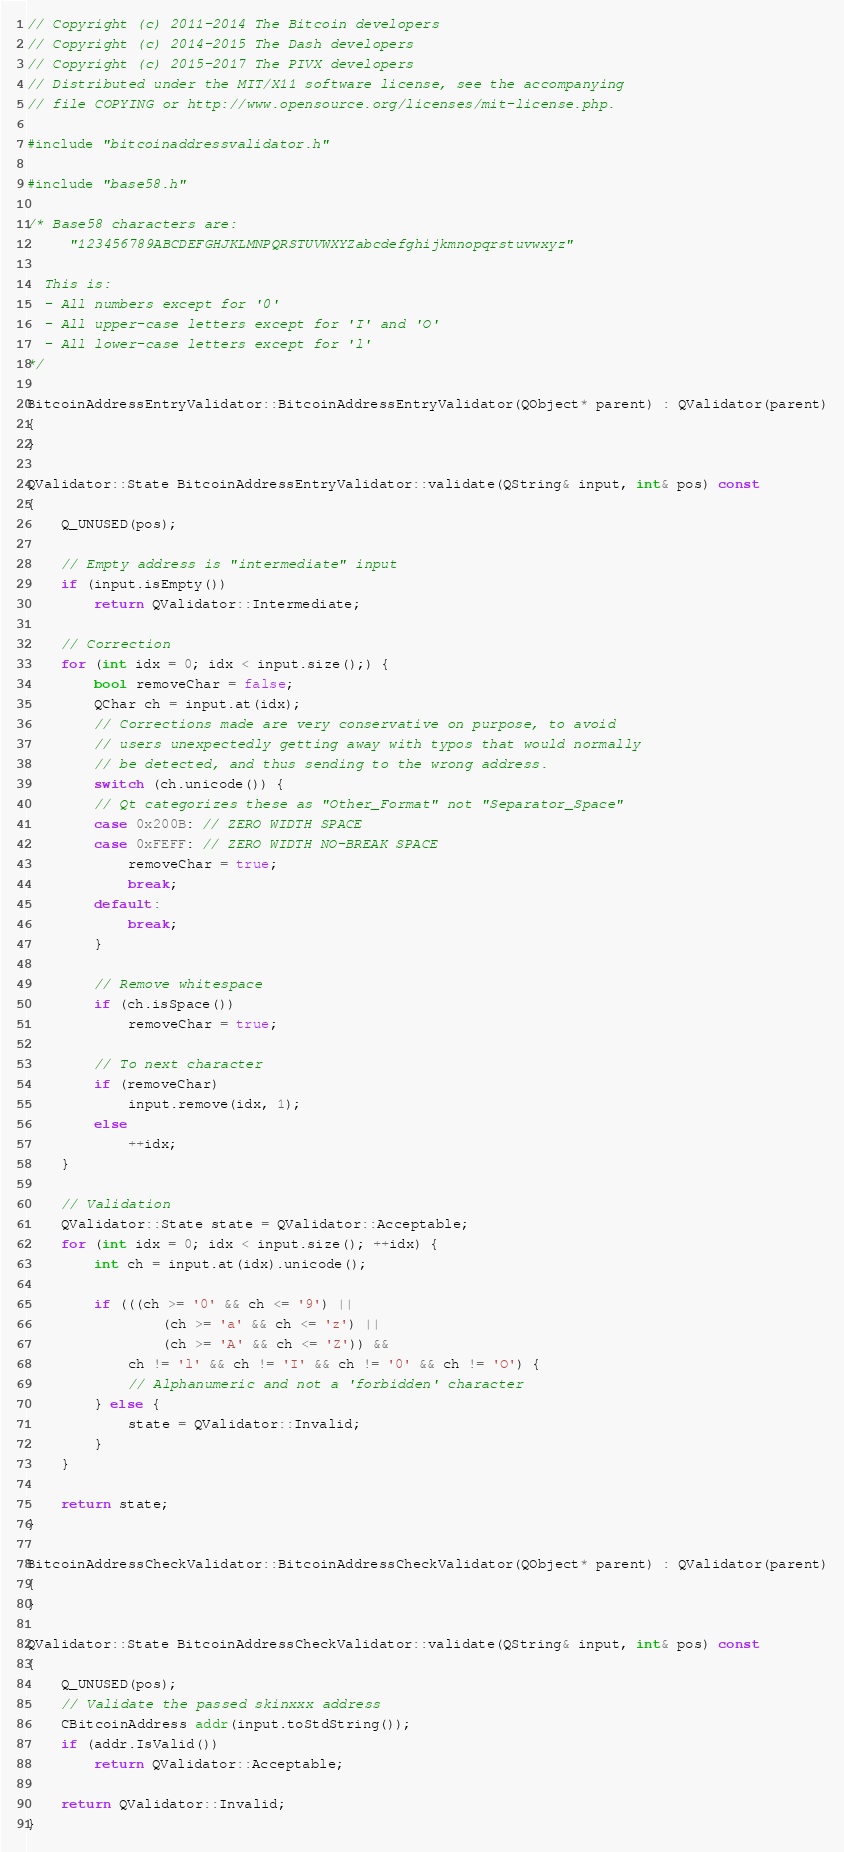<code> <loc_0><loc_0><loc_500><loc_500><_C++_>// Copyright (c) 2011-2014 The Bitcoin developers
// Copyright (c) 2014-2015 The Dash developers
// Copyright (c) 2015-2017 The PIVX developers
// Distributed under the MIT/X11 software license, see the accompanying
// file COPYING or http://www.opensource.org/licenses/mit-license.php.

#include "bitcoinaddressvalidator.h"

#include "base58.h"

/* Base58 characters are:
     "123456789ABCDEFGHJKLMNPQRSTUVWXYZabcdefghijkmnopqrstuvwxyz"

  This is:
  - All numbers except for '0'
  - All upper-case letters except for 'I' and 'O'
  - All lower-case letters except for 'l'
*/

BitcoinAddressEntryValidator::BitcoinAddressEntryValidator(QObject* parent) : QValidator(parent)
{
}

QValidator::State BitcoinAddressEntryValidator::validate(QString& input, int& pos) const
{
    Q_UNUSED(pos);

    // Empty address is "intermediate" input
    if (input.isEmpty())
        return QValidator::Intermediate;

    // Correction
    for (int idx = 0; idx < input.size();) {
        bool removeChar = false;
        QChar ch = input.at(idx);
        // Corrections made are very conservative on purpose, to avoid
        // users unexpectedly getting away with typos that would normally
        // be detected, and thus sending to the wrong address.
        switch (ch.unicode()) {
        // Qt categorizes these as "Other_Format" not "Separator_Space"
        case 0x200B: // ZERO WIDTH SPACE
        case 0xFEFF: // ZERO WIDTH NO-BREAK SPACE
            removeChar = true;
            break;
        default:
            break;
        }

        // Remove whitespace
        if (ch.isSpace())
            removeChar = true;

        // To next character
        if (removeChar)
            input.remove(idx, 1);
        else
            ++idx;
    }

    // Validation
    QValidator::State state = QValidator::Acceptable;
    for (int idx = 0; idx < input.size(); ++idx) {
        int ch = input.at(idx).unicode();

        if (((ch >= '0' && ch <= '9') ||
                (ch >= 'a' && ch <= 'z') ||
                (ch >= 'A' && ch <= 'Z')) &&
            ch != 'l' && ch != 'I' && ch != '0' && ch != 'O') {
            // Alphanumeric and not a 'forbidden' character
        } else {
            state = QValidator::Invalid;
        }
    }

    return state;
}

BitcoinAddressCheckValidator::BitcoinAddressCheckValidator(QObject* parent) : QValidator(parent)
{
}

QValidator::State BitcoinAddressCheckValidator::validate(QString& input, int& pos) const
{
    Q_UNUSED(pos);
    // Validate the passed skinxxx address
    CBitcoinAddress addr(input.toStdString());
    if (addr.IsValid())
        return QValidator::Acceptable;

    return QValidator::Invalid;
}
</code> 